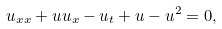Convert formula to latex. <formula><loc_0><loc_0><loc_500><loc_500>u _ { x x } + u u _ { x } - u _ { t } + u - u ^ { 2 } = 0 ,</formula> 